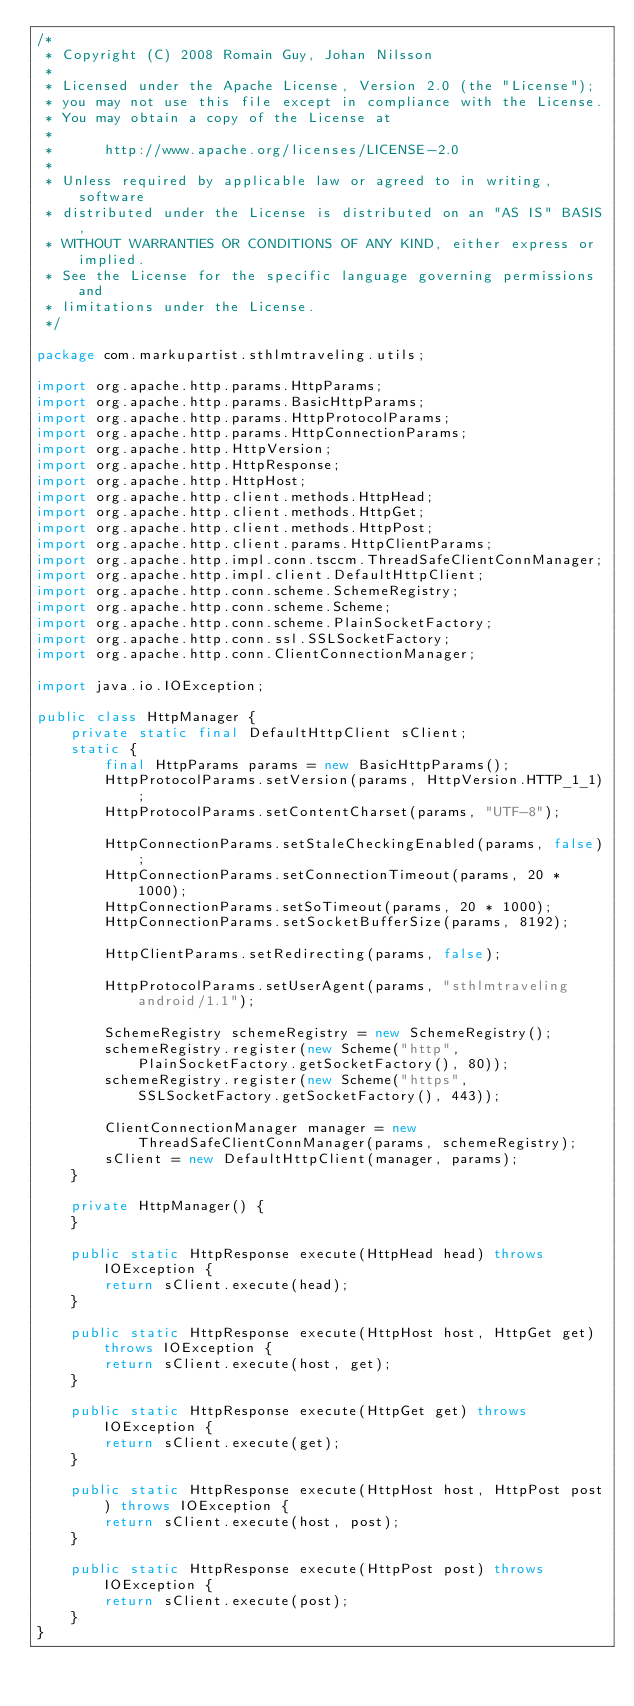Convert code to text. <code><loc_0><loc_0><loc_500><loc_500><_Java_>/*
 * Copyright (C) 2008 Romain Guy, Johan Nilsson
 *
 * Licensed under the Apache License, Version 2.0 (the "License");
 * you may not use this file except in compliance with the License.
 * You may obtain a copy of the License at
 *
 *      http://www.apache.org/licenses/LICENSE-2.0
 *
 * Unless required by applicable law or agreed to in writing, software
 * distributed under the License is distributed on an "AS IS" BASIS,
 * WITHOUT WARRANTIES OR CONDITIONS OF ANY KIND, either express or implied.
 * See the License for the specific language governing permissions and
 * limitations under the License.
 */

package com.markupartist.sthlmtraveling.utils;

import org.apache.http.params.HttpParams;
import org.apache.http.params.BasicHttpParams;
import org.apache.http.params.HttpProtocolParams;
import org.apache.http.params.HttpConnectionParams;
import org.apache.http.HttpVersion;
import org.apache.http.HttpResponse;
import org.apache.http.HttpHost;
import org.apache.http.client.methods.HttpHead;
import org.apache.http.client.methods.HttpGet;
import org.apache.http.client.methods.HttpPost;
import org.apache.http.client.params.HttpClientParams;
import org.apache.http.impl.conn.tsccm.ThreadSafeClientConnManager;
import org.apache.http.impl.client.DefaultHttpClient;
import org.apache.http.conn.scheme.SchemeRegistry;
import org.apache.http.conn.scheme.Scheme;
import org.apache.http.conn.scheme.PlainSocketFactory;
import org.apache.http.conn.ssl.SSLSocketFactory;
import org.apache.http.conn.ClientConnectionManager;

import java.io.IOException;

public class HttpManager {
    private static final DefaultHttpClient sClient;
    static {
        final HttpParams params = new BasicHttpParams();
        HttpProtocolParams.setVersion(params, HttpVersion.HTTP_1_1);
        HttpProtocolParams.setContentCharset(params, "UTF-8");

        HttpConnectionParams.setStaleCheckingEnabled(params, false);
        HttpConnectionParams.setConnectionTimeout(params, 20 * 1000);
        HttpConnectionParams.setSoTimeout(params, 20 * 1000);
        HttpConnectionParams.setSocketBufferSize(params, 8192);

        HttpClientParams.setRedirecting(params, false);

        HttpProtocolParams.setUserAgent(params, "sthlmtraveling android/1.1");

        SchemeRegistry schemeRegistry = new SchemeRegistry();
        schemeRegistry.register(new Scheme("http", PlainSocketFactory.getSocketFactory(), 80));
        schemeRegistry.register(new Scheme("https", SSLSocketFactory.getSocketFactory(), 443));

        ClientConnectionManager manager = new ThreadSafeClientConnManager(params, schemeRegistry);
        sClient = new DefaultHttpClient(manager, params);
    }

    private HttpManager() {
    }

    public static HttpResponse execute(HttpHead head) throws IOException {
        return sClient.execute(head);
    }

    public static HttpResponse execute(HttpHost host, HttpGet get) throws IOException {
        return sClient.execute(host, get);
    }

    public static HttpResponse execute(HttpGet get) throws IOException {
        return sClient.execute(get);
    }

    public static HttpResponse execute(HttpHost host, HttpPost post) throws IOException {
        return sClient.execute(host, post);
    }

    public static HttpResponse execute(HttpPost post) throws IOException {
        return sClient.execute(post);
    }
}
</code> 